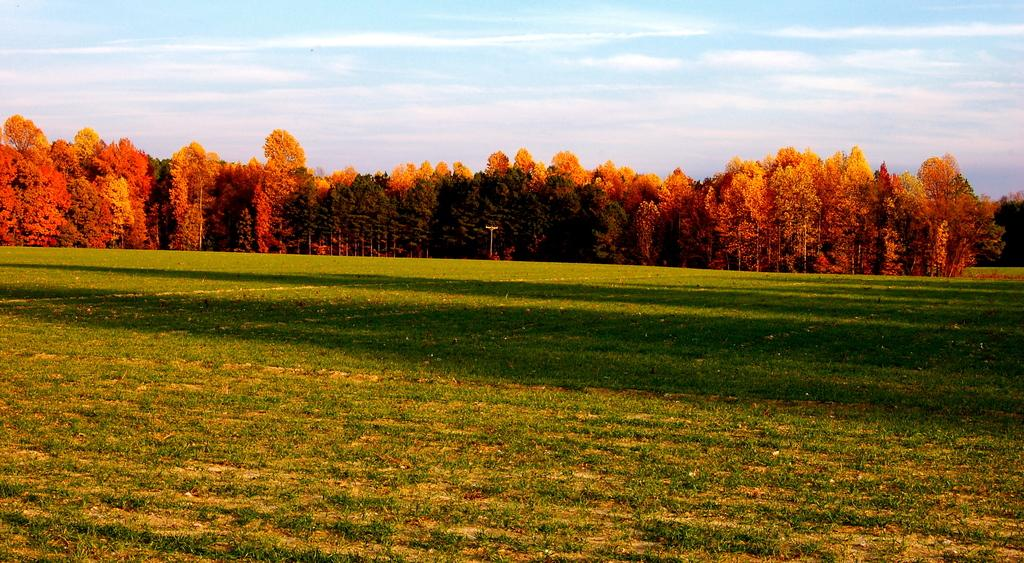What type of surface is visible in the image? There is a ground with grass in the image. What can be seen at the center of the image? There are trees at the center of the image. What is visible in the background of the image? There is a sky visible in the background of the image. What type of animal can be seen in the room in the image? There is no room or animal present in the image; it features a ground with grass and trees. 